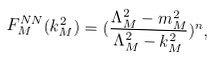Convert formula to latex. <formula><loc_0><loc_0><loc_500><loc_500>F ^ { N N } _ { M } ( k ^ { 2 } _ { M } ) = ( \frac { \Lambda ^ { 2 } _ { M } - m _ { M } ^ { 2 } } { \Lambda ^ { 2 } _ { M } - k _ { M } ^ { 2 } } ) ^ { n } ,</formula> 